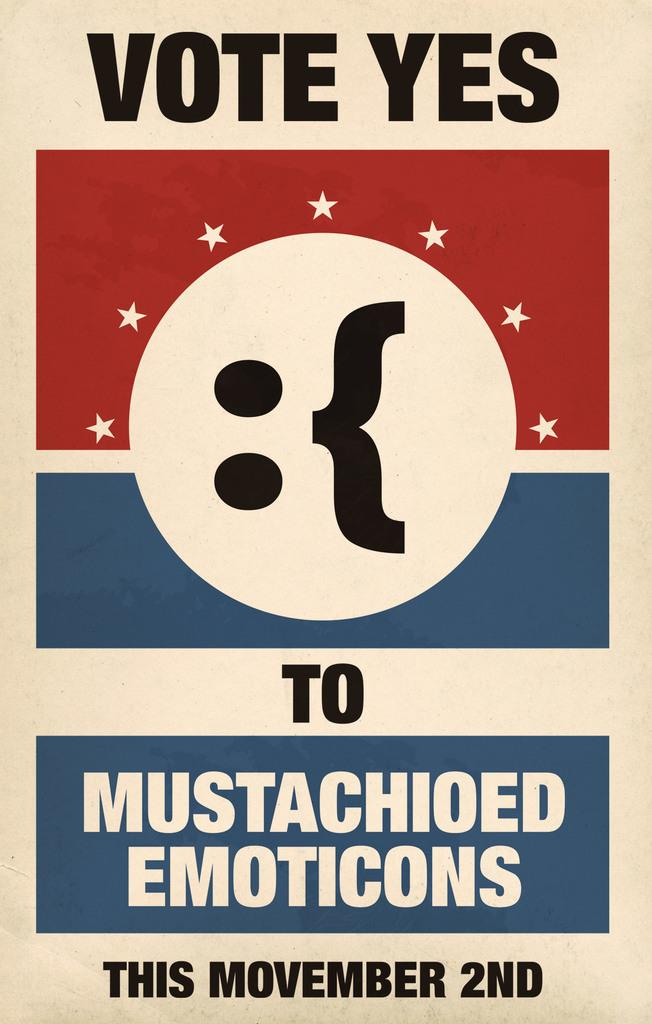What colors are used in the poster in the image? The poster is in red and blue colors. How many kittens are hiding in the mine in the image? There is no mine or kittens present in the image; it only features a poster in red and blue colors. 